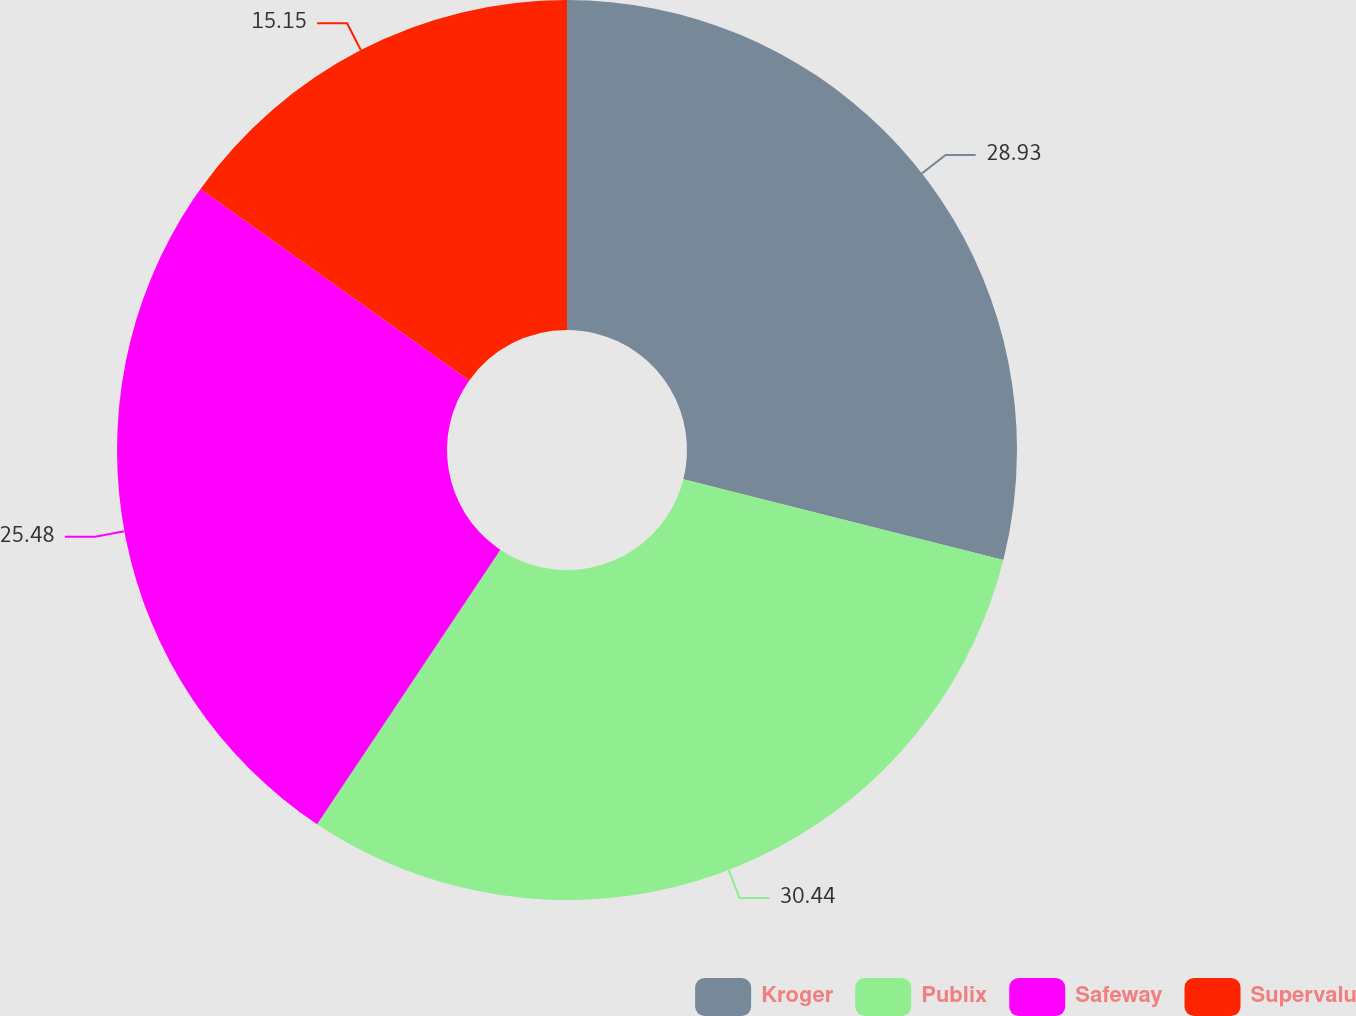Convert chart to OTSL. <chart><loc_0><loc_0><loc_500><loc_500><pie_chart><fcel>Kroger<fcel>Publix<fcel>Safeway<fcel>Supervalu<nl><fcel>28.93%<fcel>30.44%<fcel>25.48%<fcel>15.15%<nl></chart> 